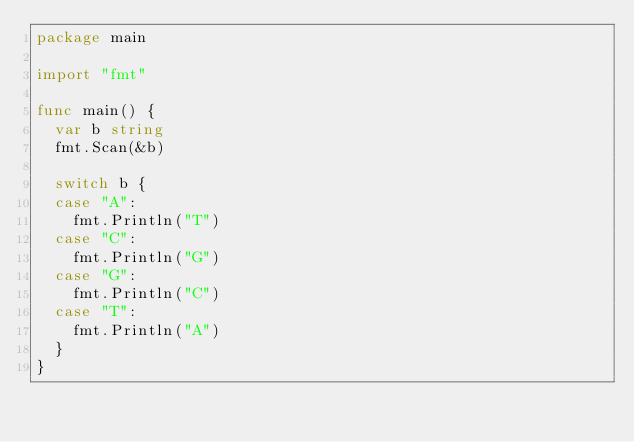Convert code to text. <code><loc_0><loc_0><loc_500><loc_500><_Go_>package main

import "fmt"

func main() {
	var b string
	fmt.Scan(&b)

	switch b {
	case "A":
		fmt.Println("T")
	case "C":
		fmt.Println("G")
	case "G":
		fmt.Println("C")
	case "T":
		fmt.Println("A")
	}
}
</code> 